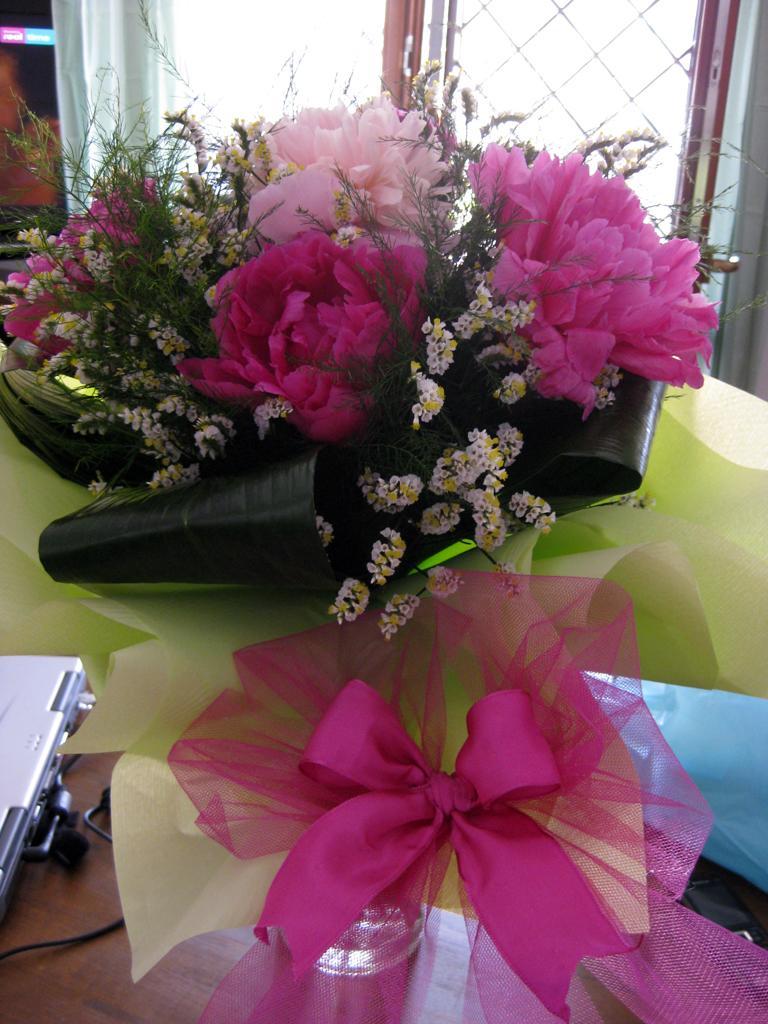Please provide a concise description of this image. In this image we can see a bouquet placed on the surface. On the left side of the image we can see a laptop with cable and on the right side of the image we can see a mobile. In the background, we can see a screen and the windows. 